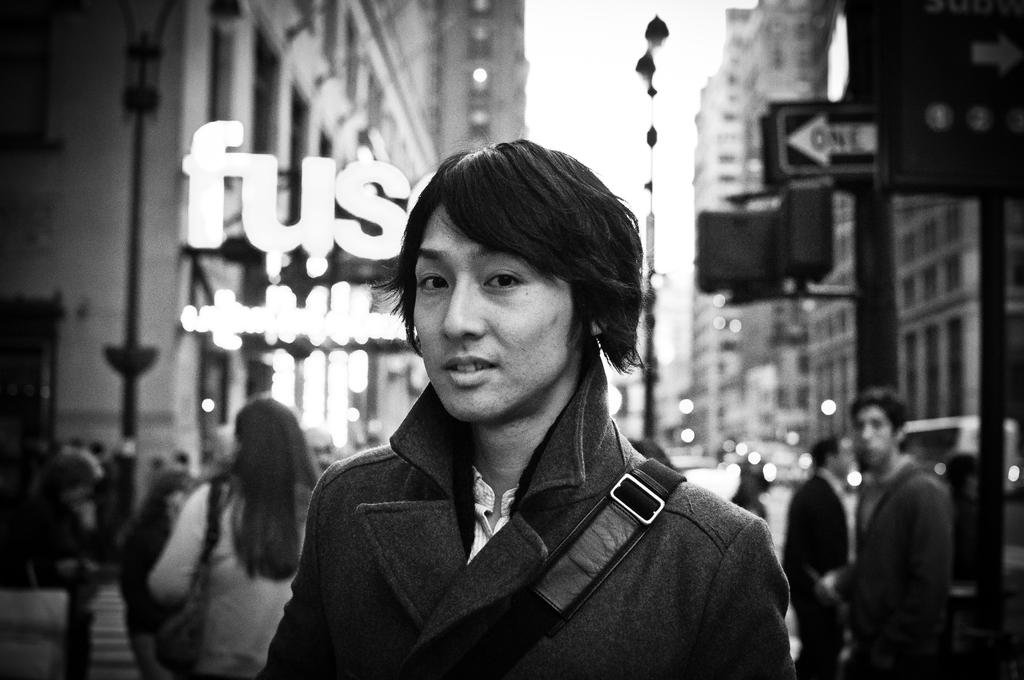What is the color scheme of the image? The image is black and white. Who is the main subject in the image? There is a person standing in the middle of the image. Are there any other people in the image? Yes, there are other people behind the person in the middle. What can be seen in the background of the image? Places and buildings are visible in the image. What type of bucket is being used by the person in the image? There is no bucket present in the image. What is the person in the image thinking about? The image does not provide any information about the person's thoughts or mind. 